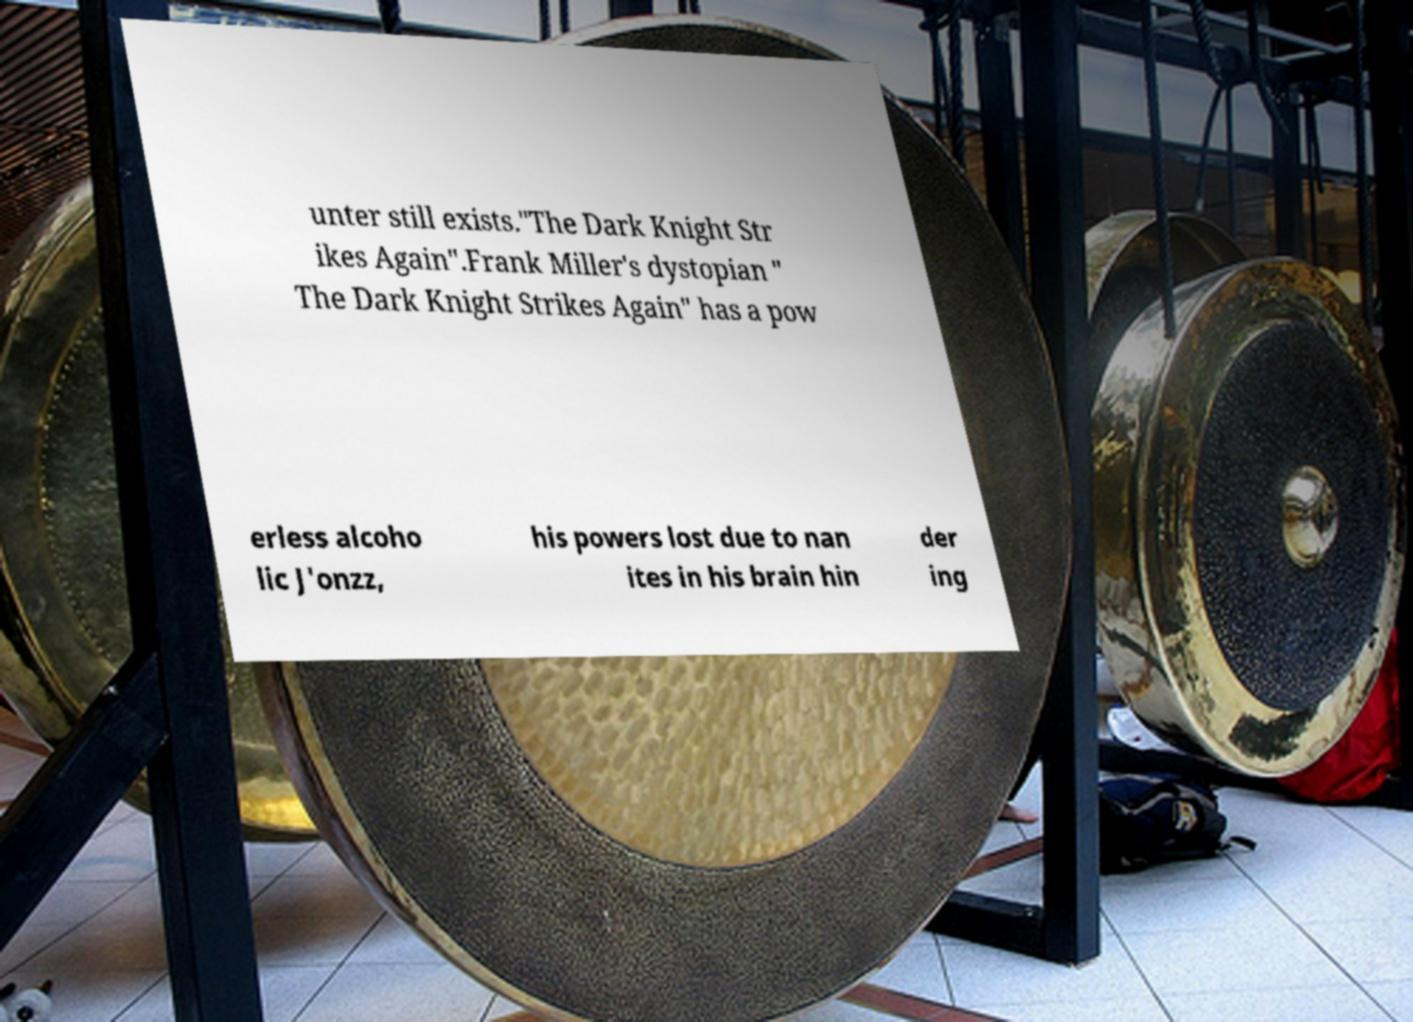Can you accurately transcribe the text from the provided image for me? unter still exists."The Dark Knight Str ikes Again".Frank Miller's dystopian " The Dark Knight Strikes Again" has a pow erless alcoho lic J'onzz, his powers lost due to nan ites in his brain hin der ing 